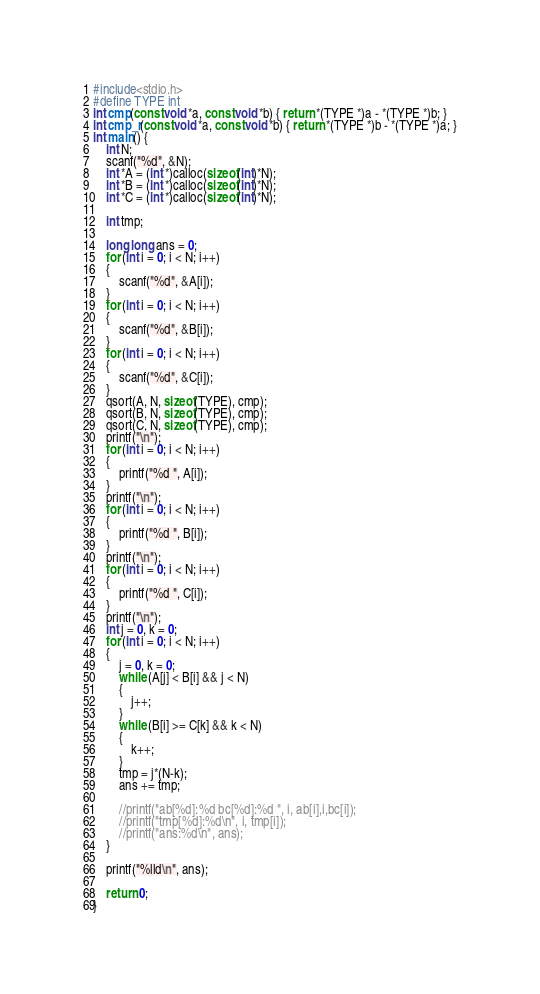Convert code to text. <code><loc_0><loc_0><loc_500><loc_500><_C_>#include<stdio.h>
#define TYPE int
int cmp(const void *a, const void *b) { return *(TYPE *)a - *(TYPE *)b; }
int cmp_r(const void *a, const void *b) { return *(TYPE *)b - *(TYPE *)a; }
int main() {
	int N;
	scanf("%d", &N);
	int *A = (int *)calloc(sizeof(int)*N);
	int *B = (int *)calloc(sizeof(int)*N);
	int *C = (int *)calloc(sizeof(int)*N);

	int tmp;

	long long ans = 0;
	for (int i = 0; i < N; i++)
	{
		scanf("%d", &A[i]);
	}
	for (int i = 0; i < N; i++)
	{
		scanf("%d", &B[i]);
	}
	for (int i = 0; i < N; i++)
	{
		scanf("%d", &C[i]);
	}
	qsort(A, N, sizeof(TYPE), cmp);
	qsort(B, N, sizeof(TYPE), cmp);
	qsort(C, N, sizeof(TYPE), cmp);
	printf("\n");
	for (int i = 0; i < N; i++)
	{
		printf("%d ", A[i]);
	}
	printf("\n");
	for (int i = 0; i < N; i++)
	{
		printf("%d ", B[i]);
	}
	printf("\n");
	for (int i = 0; i < N; i++)
	{
		printf("%d ", C[i]);
	}
	printf("\n");
	int j = 0, k = 0;
	for (int i = 0; i < N; i++)
	{
		j = 0, k = 0;
		while (A[j] < B[i] && j < N)
		{
			j++;
		}
		while (B[i] >= C[k] && k < N)
		{
			k++;
		}
		tmp = j*(N-k);
		ans += tmp;

		//printf("ab[%d]:%d bc[%d]:%d ", i, ab[i],i,bc[i]);
		//printf("tmp[%d]:%d\n", i, tmp[i]);
		//printf("ans:%d\n", ans);
	}

	printf("%lld\n", ans);

	return 0;
}</code> 